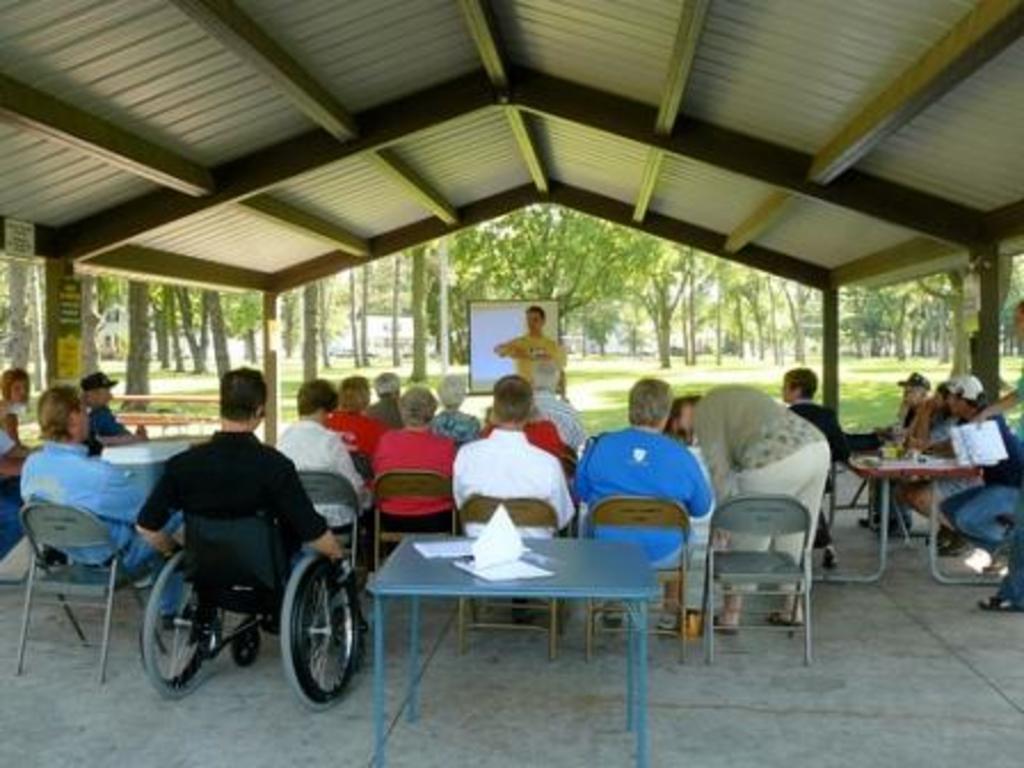In one or two sentences, can you explain what this image depicts? Here we can see a group of people sitting on chairs and there is a man in front of them giving a lecture and behind him there are trees and at the middle there is a table with papers on it 